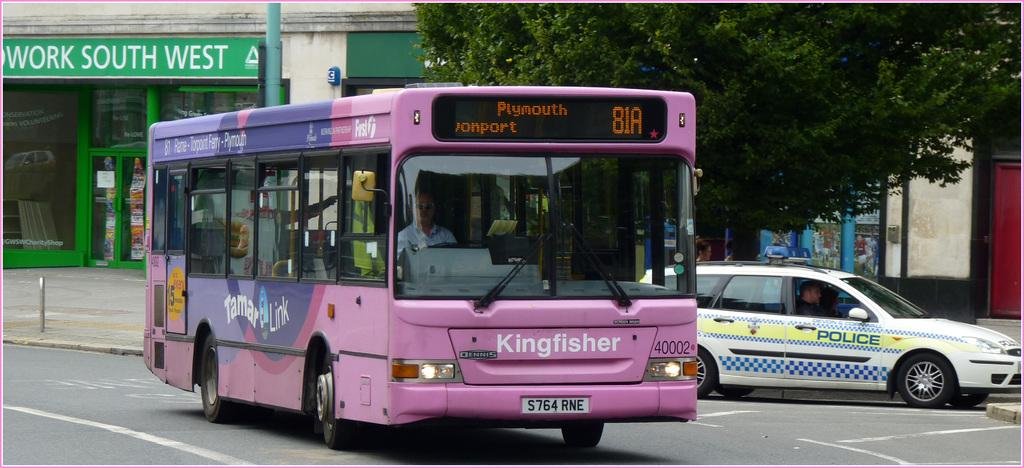Provide a one-sentence caption for the provided image. A ping bus that says Kingfisher on its front. 